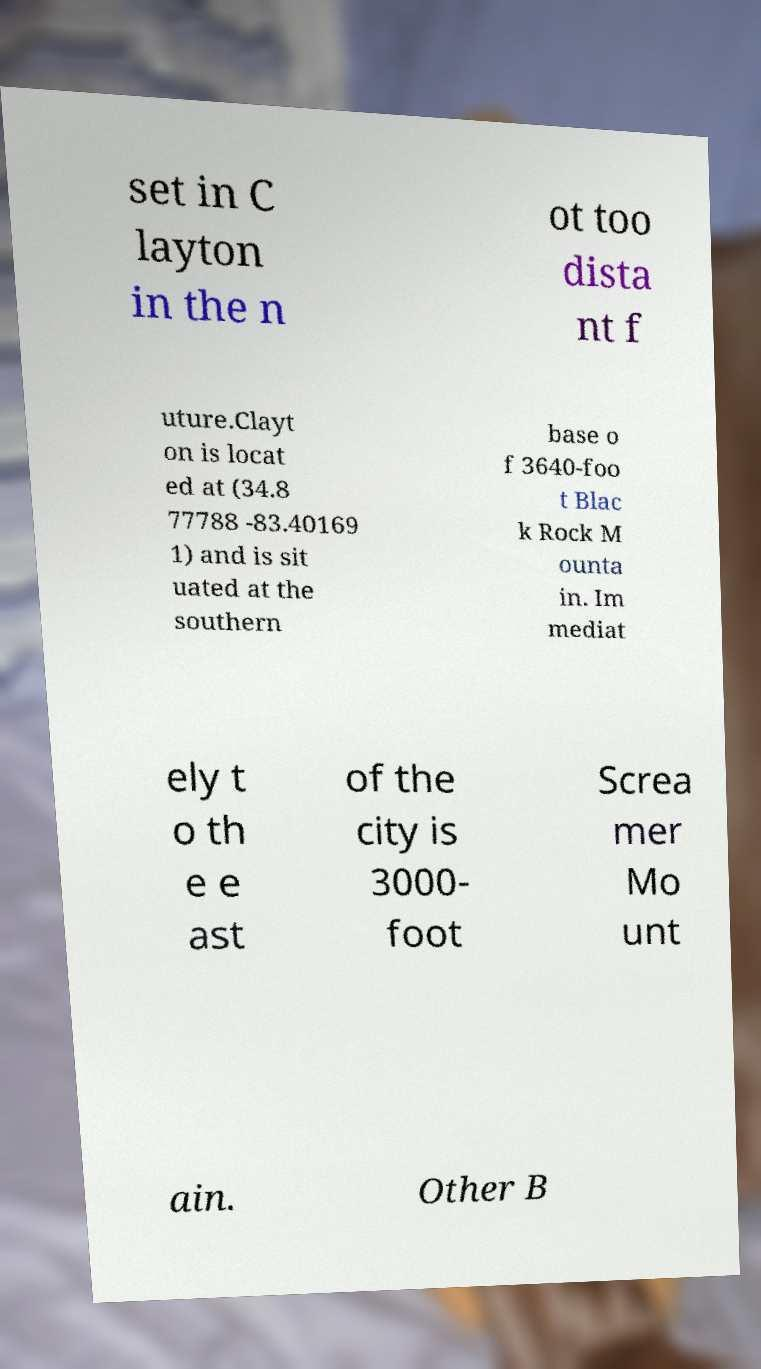For documentation purposes, I need the text within this image transcribed. Could you provide that? set in C layton in the n ot too dista nt f uture.Clayt on is locat ed at (34.8 77788 -83.40169 1) and is sit uated at the southern base o f 3640-foo t Blac k Rock M ounta in. Im mediat ely t o th e e ast of the city is 3000- foot Screa mer Mo unt ain. Other B 